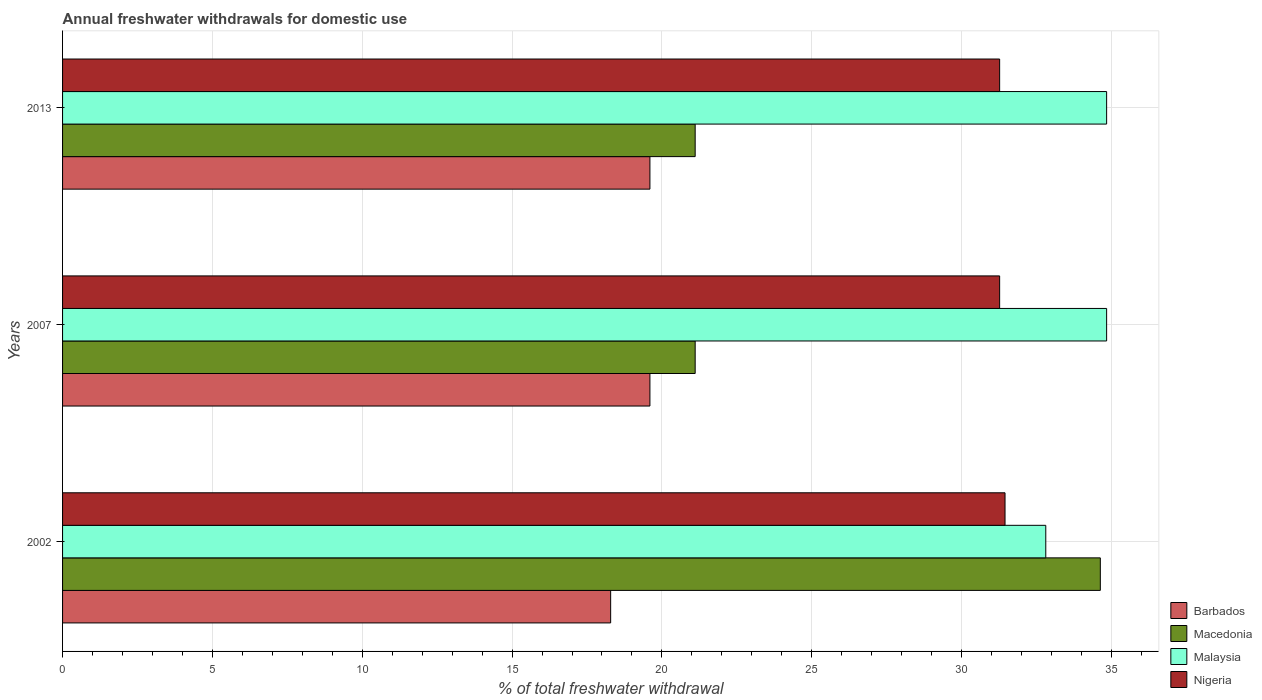How many groups of bars are there?
Give a very brief answer. 3. What is the total annual withdrawals from freshwater in Macedonia in 2007?
Your answer should be very brief. 21.11. Across all years, what is the maximum total annual withdrawals from freshwater in Malaysia?
Keep it short and to the point. 34.84. Across all years, what is the minimum total annual withdrawals from freshwater in Barbados?
Keep it short and to the point. 18.29. In which year was the total annual withdrawals from freshwater in Nigeria maximum?
Give a very brief answer. 2002. In which year was the total annual withdrawals from freshwater in Barbados minimum?
Keep it short and to the point. 2002. What is the total total annual withdrawals from freshwater in Barbados in the graph?
Make the answer very short. 57.49. What is the difference between the total annual withdrawals from freshwater in Macedonia in 2002 and that in 2013?
Offer a very short reply. 13.52. What is the difference between the total annual withdrawals from freshwater in Nigeria in 2007 and the total annual withdrawals from freshwater in Macedonia in 2013?
Keep it short and to the point. 10.16. What is the average total annual withdrawals from freshwater in Nigeria per year?
Your answer should be very brief. 31.33. In the year 2007, what is the difference between the total annual withdrawals from freshwater in Barbados and total annual withdrawals from freshwater in Macedonia?
Make the answer very short. -1.51. In how many years, is the total annual withdrawals from freshwater in Barbados greater than 1 %?
Make the answer very short. 3. What is the ratio of the total annual withdrawals from freshwater in Nigeria in 2002 to that in 2013?
Give a very brief answer. 1.01. Is the total annual withdrawals from freshwater in Malaysia in 2002 less than that in 2007?
Offer a terse response. Yes. Is the difference between the total annual withdrawals from freshwater in Barbados in 2002 and 2007 greater than the difference between the total annual withdrawals from freshwater in Macedonia in 2002 and 2007?
Give a very brief answer. No. What is the difference between the highest and the second highest total annual withdrawals from freshwater in Barbados?
Your answer should be compact. 0. What is the difference between the highest and the lowest total annual withdrawals from freshwater in Nigeria?
Provide a succinct answer. 0.18. In how many years, is the total annual withdrawals from freshwater in Nigeria greater than the average total annual withdrawals from freshwater in Nigeria taken over all years?
Make the answer very short. 1. Is the sum of the total annual withdrawals from freshwater in Barbados in 2002 and 2007 greater than the maximum total annual withdrawals from freshwater in Nigeria across all years?
Your answer should be very brief. Yes. What does the 4th bar from the top in 2007 represents?
Offer a terse response. Barbados. What does the 2nd bar from the bottom in 2002 represents?
Your answer should be compact. Macedonia. Is it the case that in every year, the sum of the total annual withdrawals from freshwater in Malaysia and total annual withdrawals from freshwater in Macedonia is greater than the total annual withdrawals from freshwater in Barbados?
Your answer should be very brief. Yes. Are all the bars in the graph horizontal?
Your answer should be compact. Yes. What is the difference between two consecutive major ticks on the X-axis?
Offer a terse response. 5. Are the values on the major ticks of X-axis written in scientific E-notation?
Your response must be concise. No. Does the graph contain any zero values?
Offer a very short reply. No. Where does the legend appear in the graph?
Keep it short and to the point. Bottom right. How many legend labels are there?
Provide a succinct answer. 4. How are the legend labels stacked?
Ensure brevity in your answer.  Vertical. What is the title of the graph?
Provide a succinct answer. Annual freshwater withdrawals for domestic use. What is the label or title of the X-axis?
Give a very brief answer. % of total freshwater withdrawal. What is the % of total freshwater withdrawal in Barbados in 2002?
Make the answer very short. 18.29. What is the % of total freshwater withdrawal of Macedonia in 2002?
Provide a short and direct response. 34.63. What is the % of total freshwater withdrawal in Malaysia in 2002?
Your answer should be very brief. 32.81. What is the % of total freshwater withdrawal of Nigeria in 2002?
Your answer should be compact. 31.45. What is the % of total freshwater withdrawal in Barbados in 2007?
Your answer should be compact. 19.6. What is the % of total freshwater withdrawal in Macedonia in 2007?
Give a very brief answer. 21.11. What is the % of total freshwater withdrawal of Malaysia in 2007?
Your answer should be compact. 34.84. What is the % of total freshwater withdrawal of Nigeria in 2007?
Provide a succinct answer. 31.27. What is the % of total freshwater withdrawal of Barbados in 2013?
Offer a very short reply. 19.6. What is the % of total freshwater withdrawal in Macedonia in 2013?
Ensure brevity in your answer.  21.11. What is the % of total freshwater withdrawal of Malaysia in 2013?
Keep it short and to the point. 34.84. What is the % of total freshwater withdrawal of Nigeria in 2013?
Keep it short and to the point. 31.27. Across all years, what is the maximum % of total freshwater withdrawal of Barbados?
Your answer should be very brief. 19.6. Across all years, what is the maximum % of total freshwater withdrawal of Macedonia?
Your answer should be very brief. 34.63. Across all years, what is the maximum % of total freshwater withdrawal of Malaysia?
Offer a very short reply. 34.84. Across all years, what is the maximum % of total freshwater withdrawal of Nigeria?
Your answer should be compact. 31.45. Across all years, what is the minimum % of total freshwater withdrawal in Barbados?
Offer a very short reply. 18.29. Across all years, what is the minimum % of total freshwater withdrawal of Macedonia?
Offer a terse response. 21.11. Across all years, what is the minimum % of total freshwater withdrawal in Malaysia?
Offer a very short reply. 32.81. Across all years, what is the minimum % of total freshwater withdrawal of Nigeria?
Your answer should be compact. 31.27. What is the total % of total freshwater withdrawal of Barbados in the graph?
Give a very brief answer. 57.49. What is the total % of total freshwater withdrawal in Macedonia in the graph?
Provide a short and direct response. 76.85. What is the total % of total freshwater withdrawal of Malaysia in the graph?
Provide a short and direct response. 102.49. What is the total % of total freshwater withdrawal in Nigeria in the graph?
Provide a short and direct response. 93.99. What is the difference between the % of total freshwater withdrawal of Barbados in 2002 and that in 2007?
Provide a succinct answer. -1.31. What is the difference between the % of total freshwater withdrawal of Macedonia in 2002 and that in 2007?
Offer a very short reply. 13.52. What is the difference between the % of total freshwater withdrawal of Malaysia in 2002 and that in 2007?
Your answer should be very brief. -2.03. What is the difference between the % of total freshwater withdrawal of Nigeria in 2002 and that in 2007?
Make the answer very short. 0.18. What is the difference between the % of total freshwater withdrawal of Barbados in 2002 and that in 2013?
Keep it short and to the point. -1.31. What is the difference between the % of total freshwater withdrawal in Macedonia in 2002 and that in 2013?
Give a very brief answer. 13.52. What is the difference between the % of total freshwater withdrawal of Malaysia in 2002 and that in 2013?
Your response must be concise. -2.03. What is the difference between the % of total freshwater withdrawal of Nigeria in 2002 and that in 2013?
Your response must be concise. 0.18. What is the difference between the % of total freshwater withdrawal of Macedonia in 2007 and that in 2013?
Your answer should be very brief. 0. What is the difference between the % of total freshwater withdrawal in Malaysia in 2007 and that in 2013?
Ensure brevity in your answer.  0. What is the difference between the % of total freshwater withdrawal of Nigeria in 2007 and that in 2013?
Provide a short and direct response. 0. What is the difference between the % of total freshwater withdrawal of Barbados in 2002 and the % of total freshwater withdrawal of Macedonia in 2007?
Provide a succinct answer. -2.82. What is the difference between the % of total freshwater withdrawal of Barbados in 2002 and the % of total freshwater withdrawal of Malaysia in 2007?
Offer a terse response. -16.55. What is the difference between the % of total freshwater withdrawal in Barbados in 2002 and the % of total freshwater withdrawal in Nigeria in 2007?
Your answer should be compact. -12.98. What is the difference between the % of total freshwater withdrawal in Macedonia in 2002 and the % of total freshwater withdrawal in Malaysia in 2007?
Offer a very short reply. -0.21. What is the difference between the % of total freshwater withdrawal of Macedonia in 2002 and the % of total freshwater withdrawal of Nigeria in 2007?
Make the answer very short. 3.36. What is the difference between the % of total freshwater withdrawal of Malaysia in 2002 and the % of total freshwater withdrawal of Nigeria in 2007?
Ensure brevity in your answer.  1.54. What is the difference between the % of total freshwater withdrawal in Barbados in 2002 and the % of total freshwater withdrawal in Macedonia in 2013?
Offer a very short reply. -2.82. What is the difference between the % of total freshwater withdrawal in Barbados in 2002 and the % of total freshwater withdrawal in Malaysia in 2013?
Give a very brief answer. -16.55. What is the difference between the % of total freshwater withdrawal in Barbados in 2002 and the % of total freshwater withdrawal in Nigeria in 2013?
Your answer should be very brief. -12.98. What is the difference between the % of total freshwater withdrawal of Macedonia in 2002 and the % of total freshwater withdrawal of Malaysia in 2013?
Your answer should be compact. -0.21. What is the difference between the % of total freshwater withdrawal in Macedonia in 2002 and the % of total freshwater withdrawal in Nigeria in 2013?
Offer a very short reply. 3.36. What is the difference between the % of total freshwater withdrawal in Malaysia in 2002 and the % of total freshwater withdrawal in Nigeria in 2013?
Your response must be concise. 1.54. What is the difference between the % of total freshwater withdrawal of Barbados in 2007 and the % of total freshwater withdrawal of Macedonia in 2013?
Make the answer very short. -1.51. What is the difference between the % of total freshwater withdrawal in Barbados in 2007 and the % of total freshwater withdrawal in Malaysia in 2013?
Give a very brief answer. -15.24. What is the difference between the % of total freshwater withdrawal of Barbados in 2007 and the % of total freshwater withdrawal of Nigeria in 2013?
Provide a short and direct response. -11.67. What is the difference between the % of total freshwater withdrawal in Macedonia in 2007 and the % of total freshwater withdrawal in Malaysia in 2013?
Keep it short and to the point. -13.73. What is the difference between the % of total freshwater withdrawal of Macedonia in 2007 and the % of total freshwater withdrawal of Nigeria in 2013?
Offer a very short reply. -10.16. What is the difference between the % of total freshwater withdrawal in Malaysia in 2007 and the % of total freshwater withdrawal in Nigeria in 2013?
Your response must be concise. 3.57. What is the average % of total freshwater withdrawal of Barbados per year?
Your answer should be compact. 19.16. What is the average % of total freshwater withdrawal of Macedonia per year?
Offer a terse response. 25.62. What is the average % of total freshwater withdrawal of Malaysia per year?
Your response must be concise. 34.16. What is the average % of total freshwater withdrawal of Nigeria per year?
Make the answer very short. 31.33. In the year 2002, what is the difference between the % of total freshwater withdrawal of Barbados and % of total freshwater withdrawal of Macedonia?
Your answer should be compact. -16.34. In the year 2002, what is the difference between the % of total freshwater withdrawal in Barbados and % of total freshwater withdrawal in Malaysia?
Offer a very short reply. -14.52. In the year 2002, what is the difference between the % of total freshwater withdrawal in Barbados and % of total freshwater withdrawal in Nigeria?
Provide a short and direct response. -13.16. In the year 2002, what is the difference between the % of total freshwater withdrawal in Macedonia and % of total freshwater withdrawal in Malaysia?
Offer a terse response. 1.82. In the year 2002, what is the difference between the % of total freshwater withdrawal of Macedonia and % of total freshwater withdrawal of Nigeria?
Your answer should be compact. 3.18. In the year 2002, what is the difference between the % of total freshwater withdrawal of Malaysia and % of total freshwater withdrawal of Nigeria?
Your answer should be very brief. 1.36. In the year 2007, what is the difference between the % of total freshwater withdrawal of Barbados and % of total freshwater withdrawal of Macedonia?
Provide a short and direct response. -1.51. In the year 2007, what is the difference between the % of total freshwater withdrawal in Barbados and % of total freshwater withdrawal in Malaysia?
Offer a terse response. -15.24. In the year 2007, what is the difference between the % of total freshwater withdrawal of Barbados and % of total freshwater withdrawal of Nigeria?
Give a very brief answer. -11.67. In the year 2007, what is the difference between the % of total freshwater withdrawal in Macedonia and % of total freshwater withdrawal in Malaysia?
Your response must be concise. -13.73. In the year 2007, what is the difference between the % of total freshwater withdrawal of Macedonia and % of total freshwater withdrawal of Nigeria?
Your answer should be compact. -10.16. In the year 2007, what is the difference between the % of total freshwater withdrawal in Malaysia and % of total freshwater withdrawal in Nigeria?
Provide a short and direct response. 3.57. In the year 2013, what is the difference between the % of total freshwater withdrawal in Barbados and % of total freshwater withdrawal in Macedonia?
Ensure brevity in your answer.  -1.51. In the year 2013, what is the difference between the % of total freshwater withdrawal of Barbados and % of total freshwater withdrawal of Malaysia?
Offer a terse response. -15.24. In the year 2013, what is the difference between the % of total freshwater withdrawal in Barbados and % of total freshwater withdrawal in Nigeria?
Give a very brief answer. -11.67. In the year 2013, what is the difference between the % of total freshwater withdrawal of Macedonia and % of total freshwater withdrawal of Malaysia?
Ensure brevity in your answer.  -13.73. In the year 2013, what is the difference between the % of total freshwater withdrawal in Macedonia and % of total freshwater withdrawal in Nigeria?
Give a very brief answer. -10.16. In the year 2013, what is the difference between the % of total freshwater withdrawal of Malaysia and % of total freshwater withdrawal of Nigeria?
Provide a succinct answer. 3.57. What is the ratio of the % of total freshwater withdrawal in Barbados in 2002 to that in 2007?
Your response must be concise. 0.93. What is the ratio of the % of total freshwater withdrawal in Macedonia in 2002 to that in 2007?
Your response must be concise. 1.64. What is the ratio of the % of total freshwater withdrawal in Malaysia in 2002 to that in 2007?
Keep it short and to the point. 0.94. What is the ratio of the % of total freshwater withdrawal in Nigeria in 2002 to that in 2007?
Keep it short and to the point. 1.01. What is the ratio of the % of total freshwater withdrawal in Barbados in 2002 to that in 2013?
Provide a succinct answer. 0.93. What is the ratio of the % of total freshwater withdrawal of Macedonia in 2002 to that in 2013?
Ensure brevity in your answer.  1.64. What is the ratio of the % of total freshwater withdrawal in Malaysia in 2002 to that in 2013?
Your response must be concise. 0.94. What is the ratio of the % of total freshwater withdrawal in Macedonia in 2007 to that in 2013?
Provide a succinct answer. 1. What is the difference between the highest and the second highest % of total freshwater withdrawal in Barbados?
Your response must be concise. 0. What is the difference between the highest and the second highest % of total freshwater withdrawal of Macedonia?
Your answer should be compact. 13.52. What is the difference between the highest and the second highest % of total freshwater withdrawal in Malaysia?
Make the answer very short. 0. What is the difference between the highest and the second highest % of total freshwater withdrawal of Nigeria?
Keep it short and to the point. 0.18. What is the difference between the highest and the lowest % of total freshwater withdrawal in Barbados?
Give a very brief answer. 1.31. What is the difference between the highest and the lowest % of total freshwater withdrawal in Macedonia?
Provide a short and direct response. 13.52. What is the difference between the highest and the lowest % of total freshwater withdrawal of Malaysia?
Provide a short and direct response. 2.03. What is the difference between the highest and the lowest % of total freshwater withdrawal of Nigeria?
Provide a short and direct response. 0.18. 